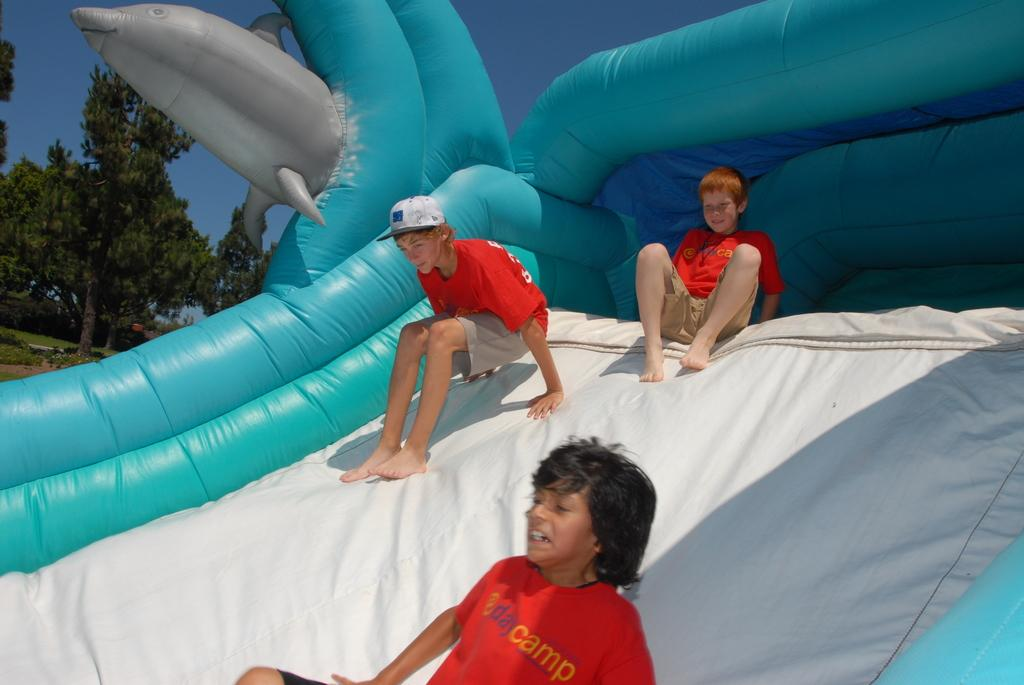What are the people in the image doing? The people in the image are sliding on an inflatable. What can be seen in the background of the image? There is a group of trees visible in the background. How would you describe the sky in the image? The sky appears cloudy. What type of horn can be heard in the image? There is no horn present or audible in the image. Is there an office visible in the image? No, there is no office present in the image. 